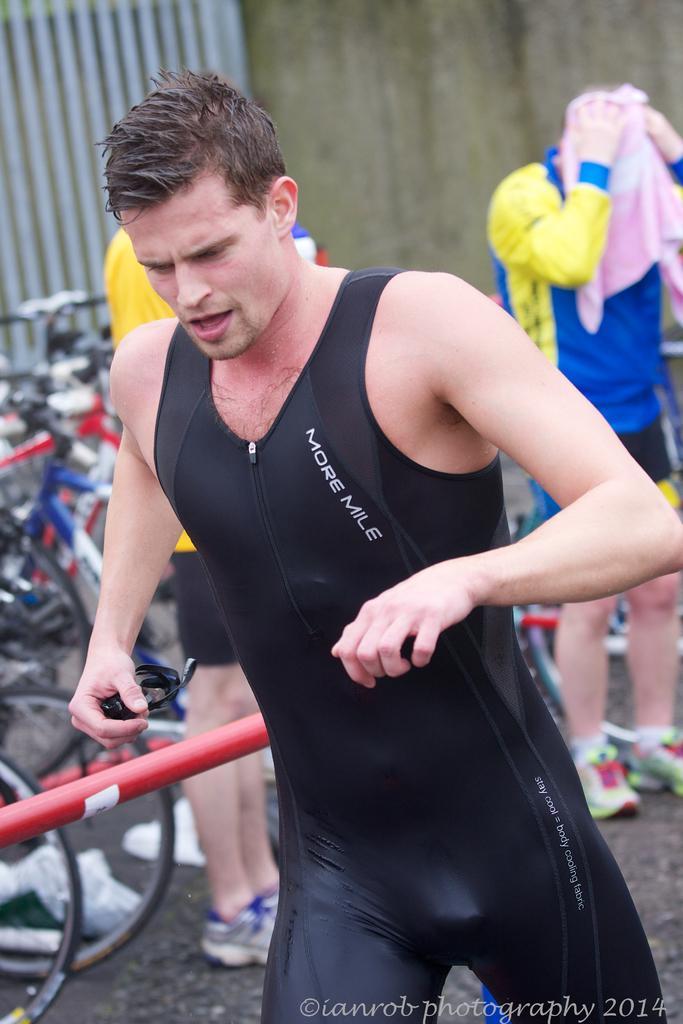Could you give a brief overview of what you see in this image? In this image I can see a man wearing a black dress. In the background I can see two more people where one has covered his face by a towel. I can also see number of bicycles in the background. 